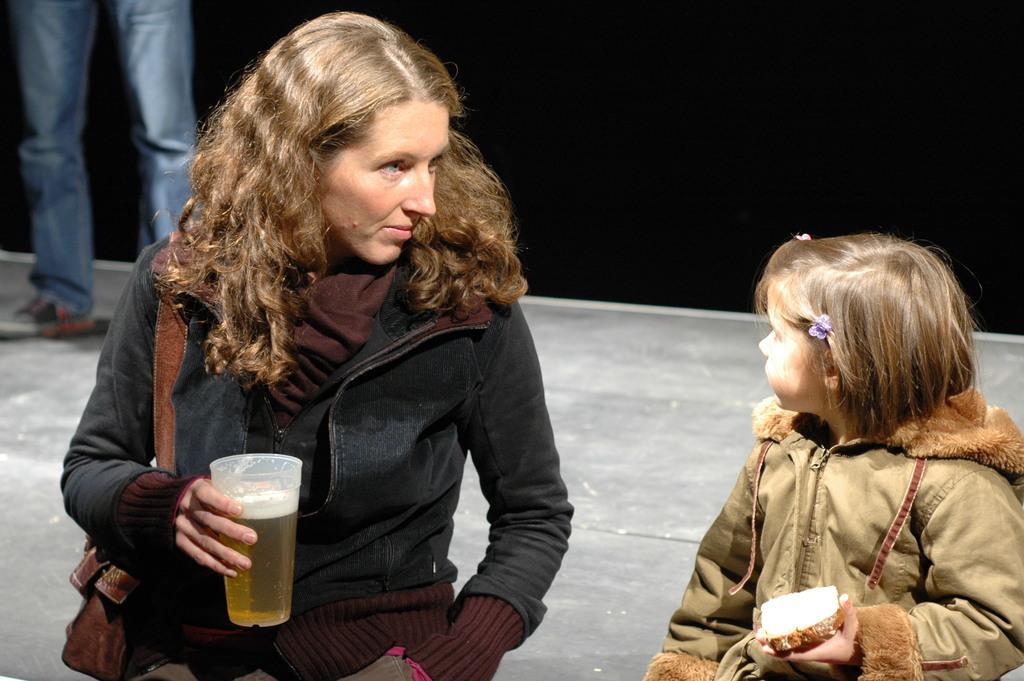How would you summarize this image in a sentence or two? In this picture we can see a woman and a girl in the middle. She is holding a glass with her hand. And this is the bag. 